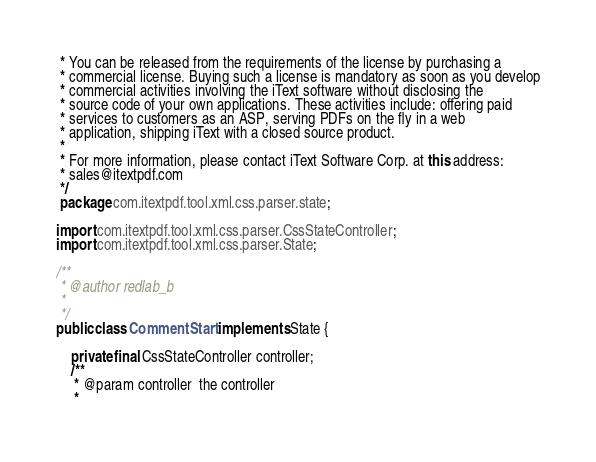<code> <loc_0><loc_0><loc_500><loc_500><_Java_> * You can be released from the requirements of the license by purchasing a
 * commercial license. Buying such a license is mandatory as soon as you develop
 * commercial activities involving the iText software without disclosing the
 * source code of your own applications. These activities include: offering paid
 * services to customers as an ASP, serving PDFs on the fly in a web
 * application, shipping iText with a closed source product.
 *
 * For more information, please contact iText Software Corp. at this address:
 * sales@itextpdf.com
 */
 package com.itextpdf.tool.xml.css.parser.state;

import com.itextpdf.tool.xml.css.parser.CssStateController;
import com.itextpdf.tool.xml.css.parser.State;

/**
 * @author redlab_b
 *
 */
public class CommentStart implements State {

	private final CssStateController controller;
	/**
	 * @param controller  the controller
	 *</code> 